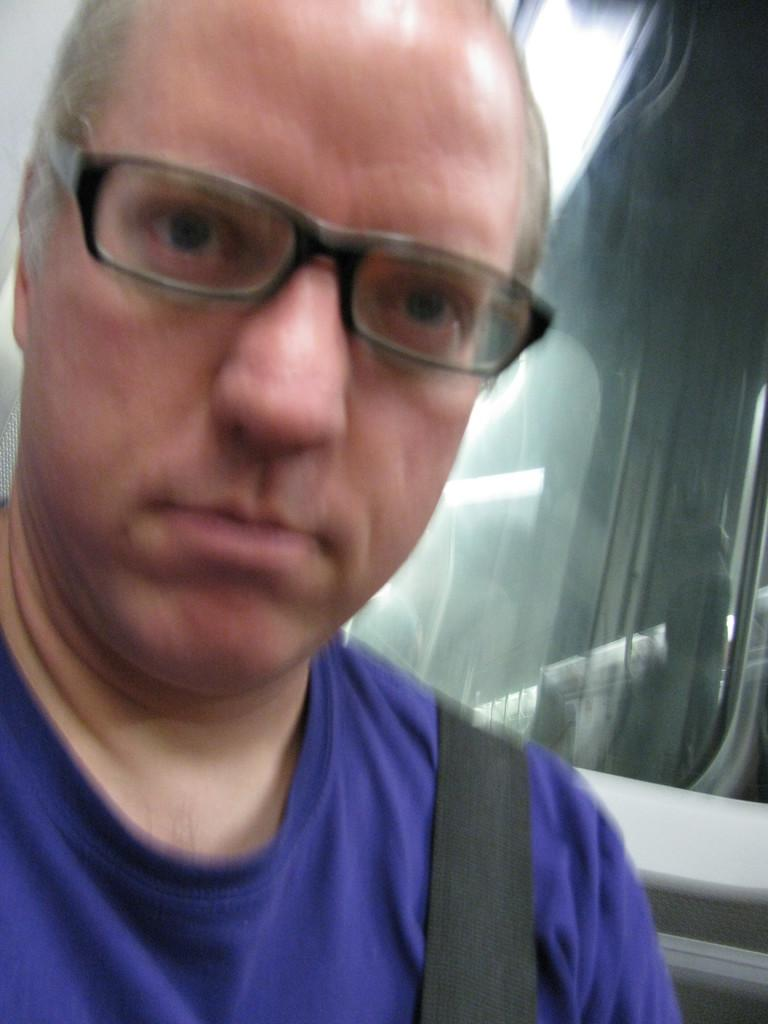Who is present in the image? There is a man in the image. What is the man doing in the image? The man is looking to his side. What is the man wearing in the image? The man is wearing a blue t-shirt and spectacles. What object can be seen on the right side of the image? There is a glass on the right side of the image. What type of clocks can be seen on the man's wrist in the image? There are no clocks visible on the man's wrist in the image. What act is the man performing in the image? The image does not depict the man performing any specific act; he is simply looking to his side. 